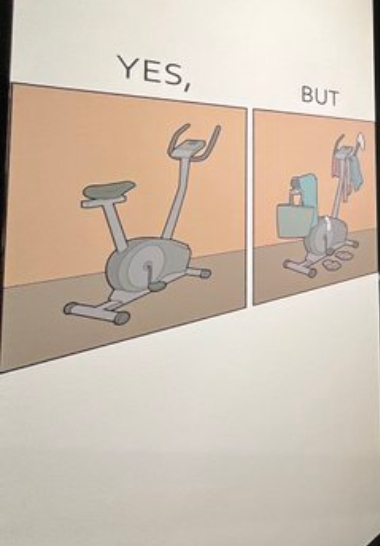Describe the satirical element in this image. The image is funny because while the intention of getting a cycling exercise machine is to do workout, it is being used for hanging clothes and other things on it. 